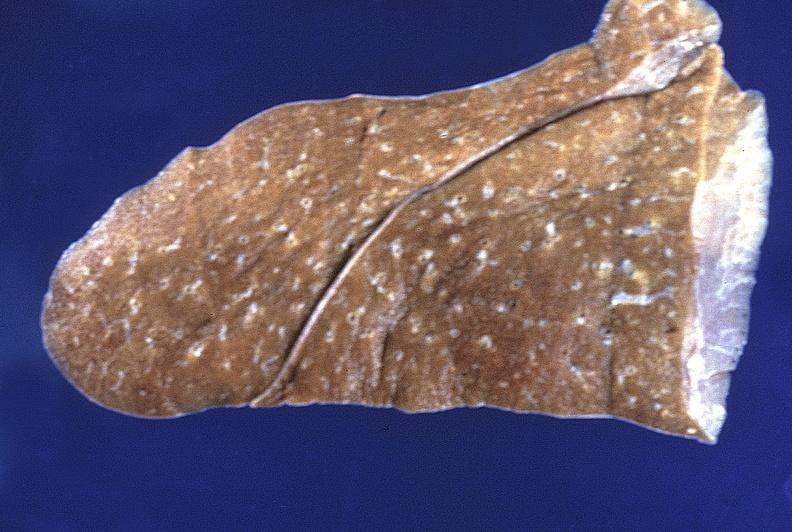s respiratory present?
Answer the question using a single word or phrase. Yes 